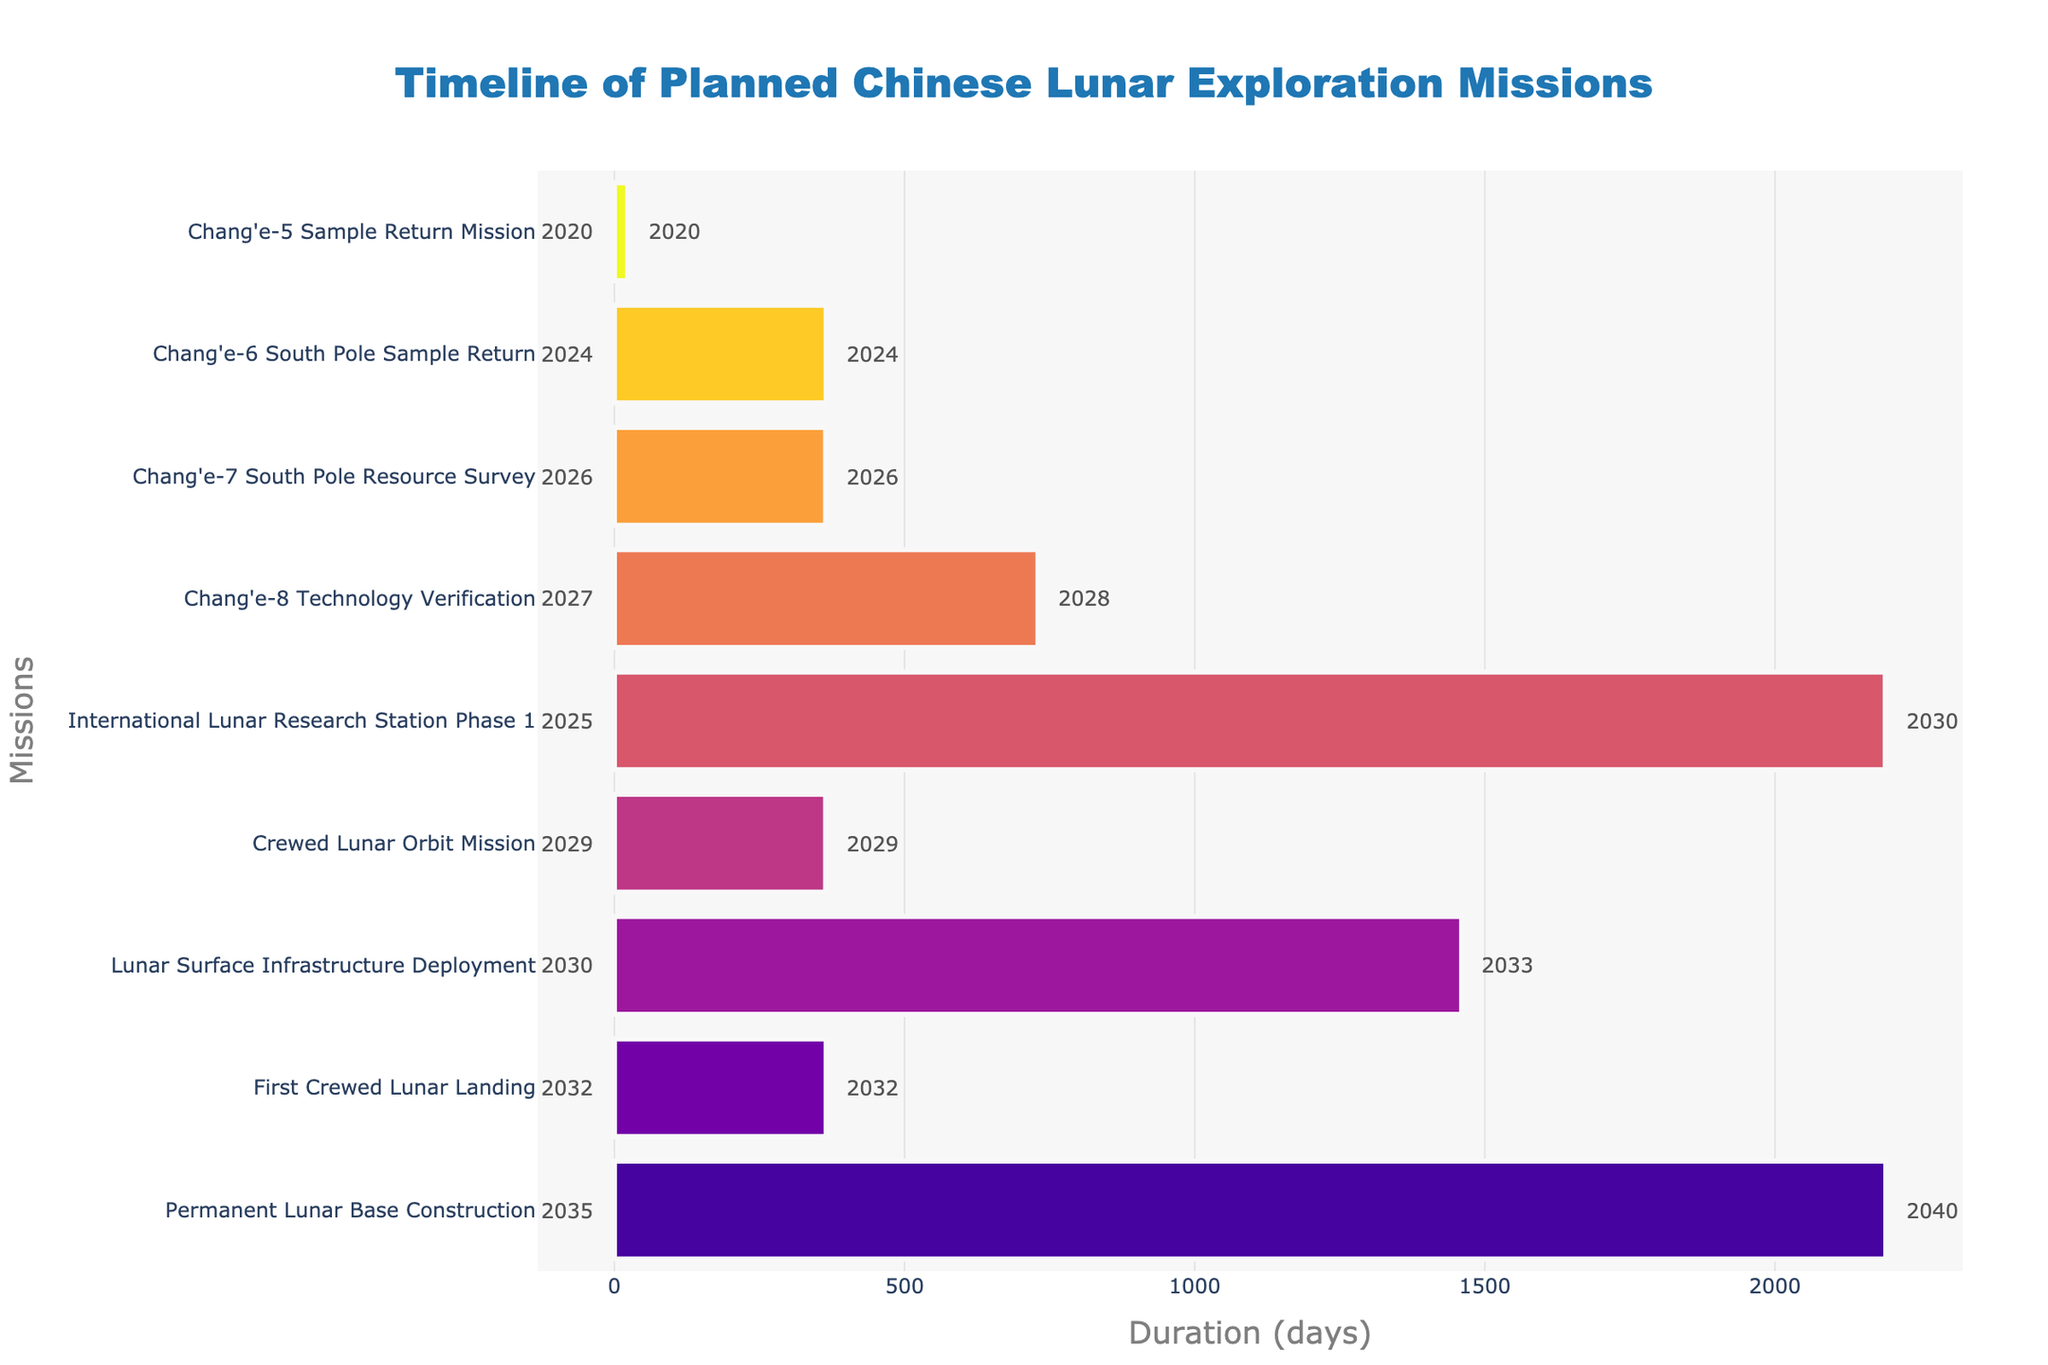What's the title of the Gantt chart? The title is located at the top center of the figure. It reads "Timeline of Planned Chinese Lunar Exploration Missions."
Answer: Timeline of Planned Chinese Lunar Exploration Missions What is the duration of the 'Chang'e-8 Technology Verification' mission in days? Look at the bar corresponding to 'Chang'e-8 Technology Verification.' Check the duration from the hover text.
Answer: 730 days Which mission starts the earliest and which one starts the latest? Identify the missions with the earliest and latest start dates by looking at the leftmost and rightmost start years annotated. The earliest is in 2020 and the latest is in 2035.
Answer: Chang'e-5 Sample Return Mission and Permanent Lunar Base Construction What is the longest mission in duration, and how many days does it take? Compare the lengths of all the bars. The longest bar represents the mission that takes the most days.
Answer: Permanent Lunar Base Construction, 2191 days Which mission(s) end in the year 2029? Look at the right annotations for the end years. Identify the missions ending in 2029.
Answer: International Lunar Research Station Phase 1 and Crewed Lunar Orbit Mission Which mission has the shortest duration? Identify the shortest bar in terms of length, which directly indicates the mission with the shortest duration.
Answer: Chang'e-5 Sample Return Mission How many missions start in the year 2030 or later? Count the number of bars with start annotations of 2030 or a later year. There are three missions: Lunar Surface Infrastructure Deployment, First Crewed Lunar Landing, and Permanent Lunar Base Construction.
Answer: 3 missions What is the total duration in days of the 'Chang'e-6' and the 'Chang'e-7' missions combined? Add the durations of 'Chang'e-6 South Pole Sample Return' and 'Chang'e-7 South Pole Resource Survey' from the hover texts.
Answer: 730 + 365 = 1095 days Which mission overlaps in time with the 'International Lunar Research Station Phase 1'? Look for the bars that have a timeline intersecting with 'International Lunar Research Station Phase 1' (2025-2030).
Answer: Chang'e-7 South Pole Resource Survey overlaps from 2026 to 2026 In which years are the missions 'Chang'e-7' and 'Chang'e-8' expected to finish? Check the end annotations of the 'Chang'e-7 South Pole Resource Survey' and 'Chang'e-8 Technology Verification' bars for the years they end.
Answer: 2026 and 2028 